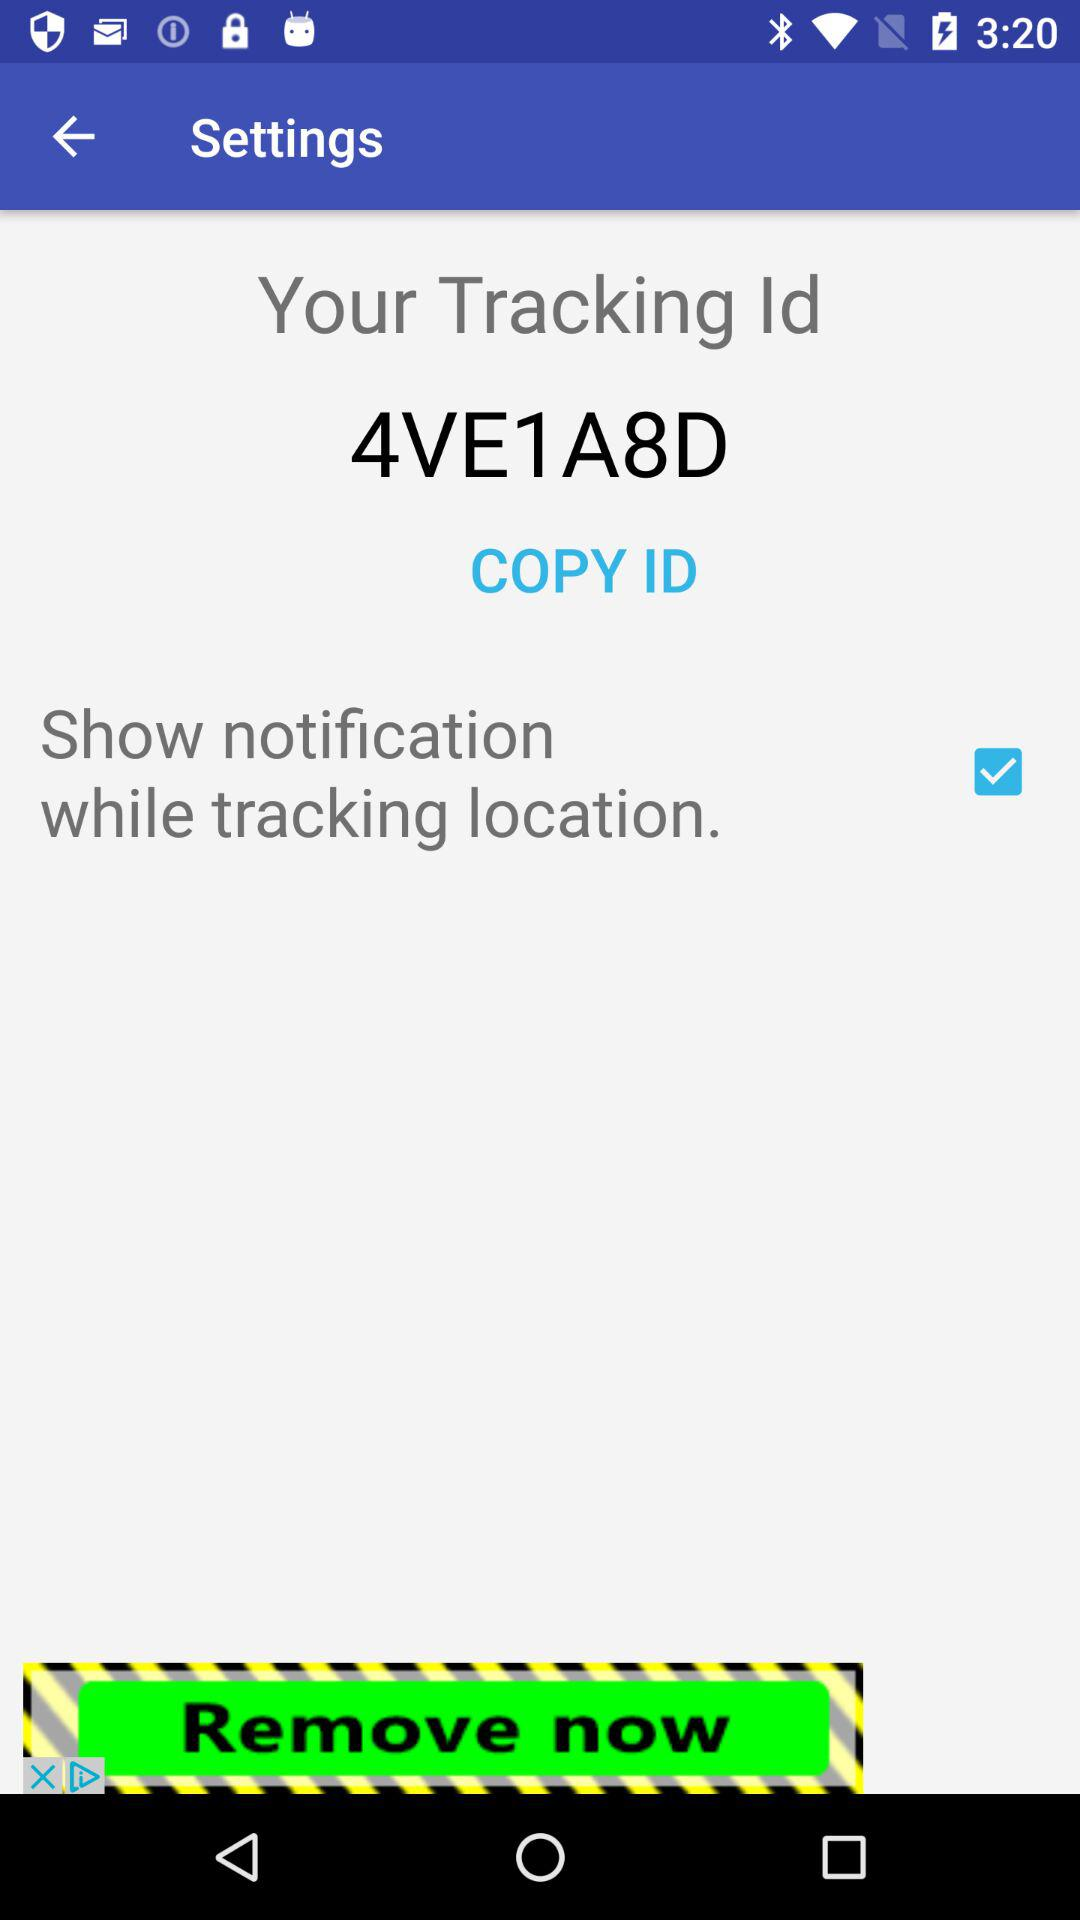What is the tracking Id? The tracking Id is 4VE1A8D. 